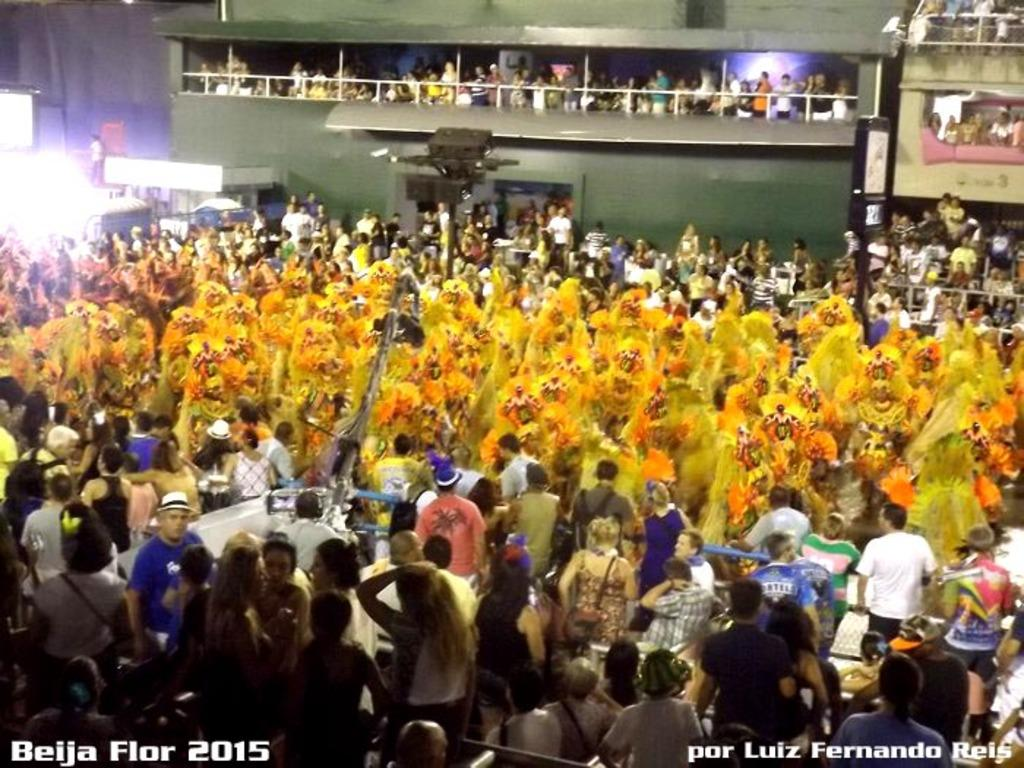How many people are in the image? There are people present in the image. What can be observed about the people in the center of the image? Some people are wearing yellow costumes and are located at the center of the image. Are there people located in any other areas of the image? Yes, there are people present at the top of the image. Is there any quicksand visible in the image? No, there is no quicksand present in the image. What type of dinosaurs can be seen interacting with the people in the image? There are no dinosaurs present in the image. 